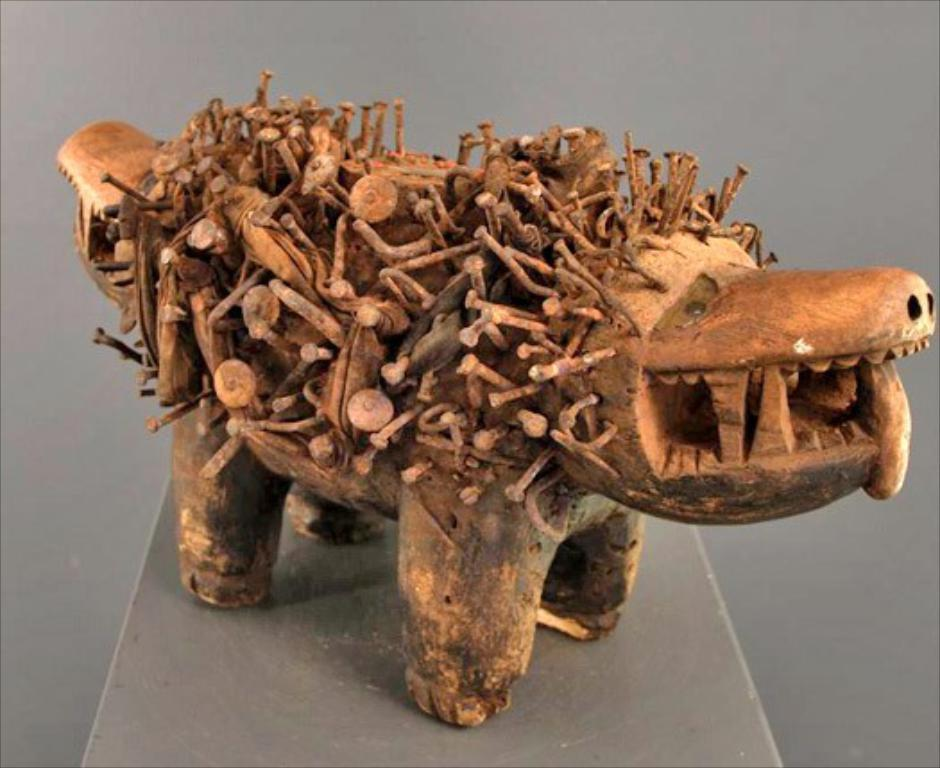What type of material is the object in the image made of? The object in the image is made of wood. Can you describe the object's location in the image? The wooden object is on a surface. What type of wire can be seen connecting the wooden object to the moon in the image? There is no wire or moon present in the image; it only features a wooden object on a surface. 